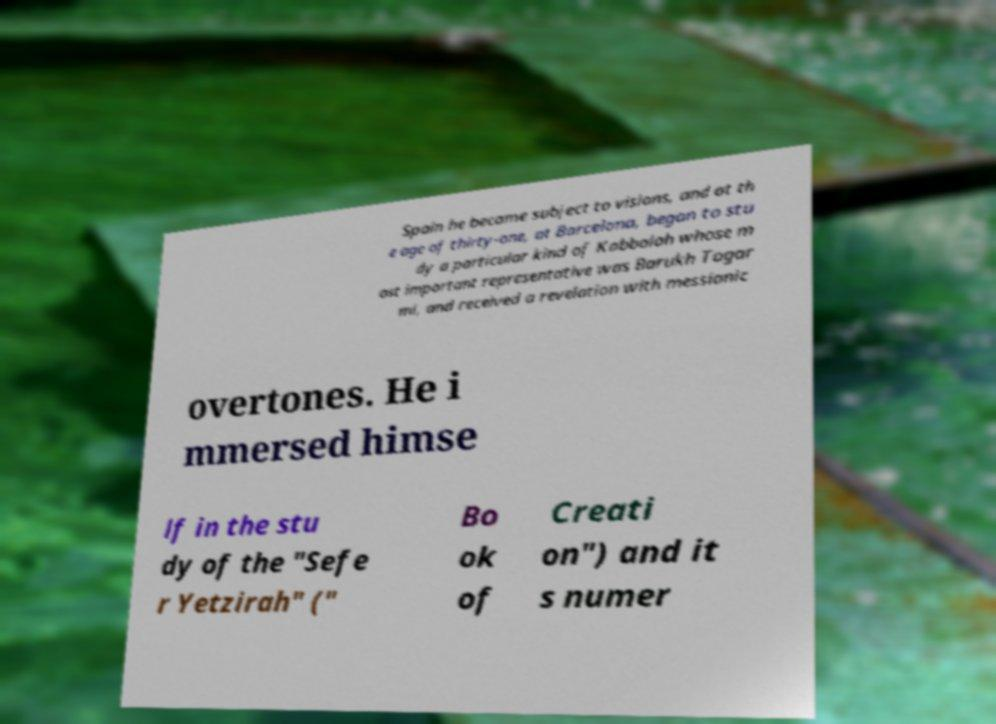There's text embedded in this image that I need extracted. Can you transcribe it verbatim? Spain he became subject to visions, and at th e age of thirty-one, at Barcelona, began to stu dy a particular kind of Kabbalah whose m ost important representative was Barukh Togar mi, and received a revelation with messianic overtones. He i mmersed himse lf in the stu dy of the "Sefe r Yetzirah" (" Bo ok of Creati on") and it s numer 